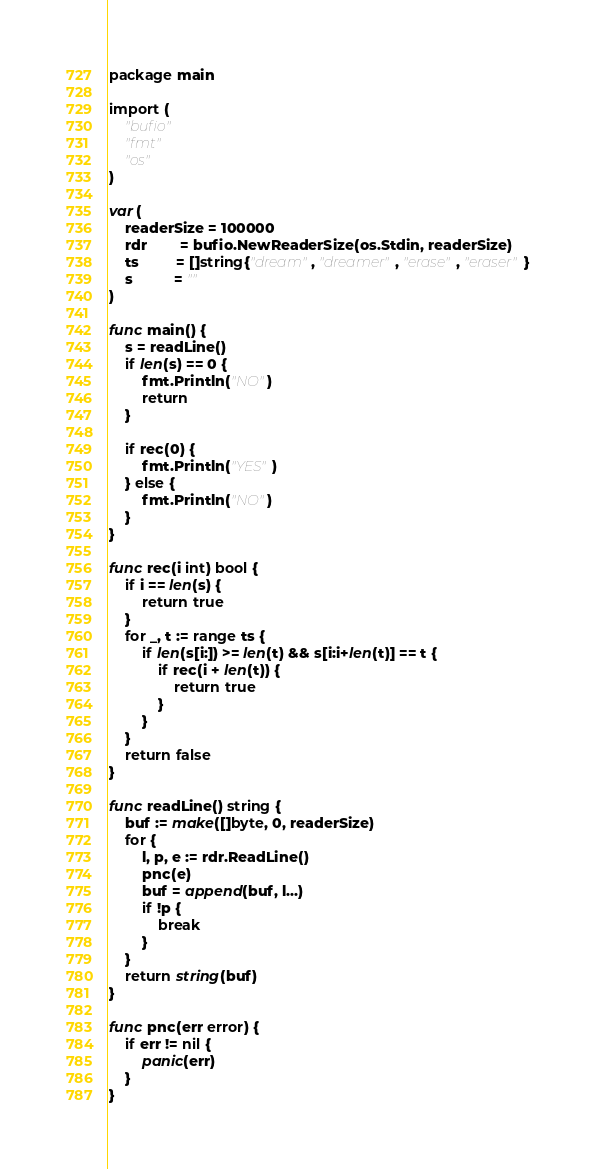<code> <loc_0><loc_0><loc_500><loc_500><_Go_>package main

import (
	"bufio"
	"fmt"
	"os"
)

var (
	readerSize = 100000
	rdr        = bufio.NewReaderSize(os.Stdin, readerSize)
	ts         = []string{"dream", "dreamer", "erase", "eraser"}
	s          = ""
)

func main() {
	s = readLine()
	if len(s) == 0 {
		fmt.Println("NO")
		return
	}

	if rec(0) {
		fmt.Println("YES")
	} else {
		fmt.Println("NO")
	}
}

func rec(i int) bool {
	if i == len(s) {
		return true
	}
	for _, t := range ts {
		if len(s[i:]) >= len(t) && s[i:i+len(t)] == t {
			if rec(i + len(t)) {
				return true
			}
		}
	}
	return false
}

func readLine() string {
	buf := make([]byte, 0, readerSize)
	for {
		l, p, e := rdr.ReadLine()
		pnc(e)
		buf = append(buf, l...)
		if !p {
			break
		}
	}
	return string(buf)
}

func pnc(err error) {
	if err != nil {
		panic(err)
	}
}
</code> 